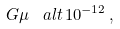<formula> <loc_0><loc_0><loc_500><loc_500>G \mu \, \ a l t \, 1 0 ^ { - 1 2 } \, ,</formula> 